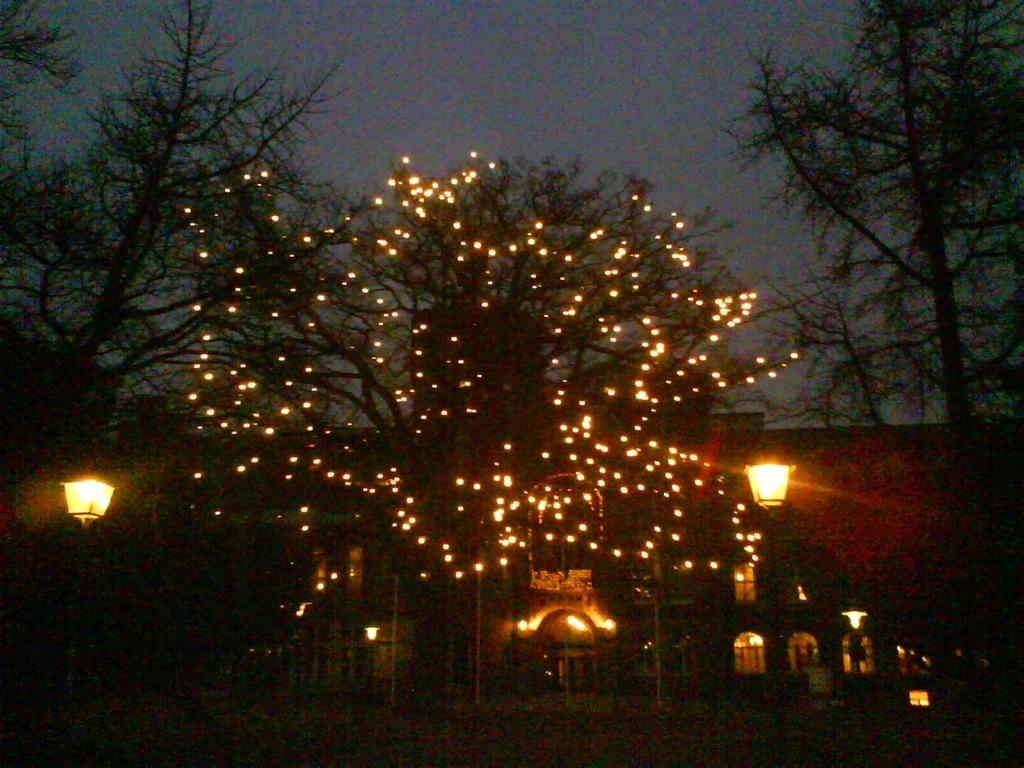What type of structure is present in the image? There is a building in the image. What other objects can be seen in the image? There are light poles and trees in the image. What is visible in the background of the image? The sky is visible in the image. Can you describe a specific tree in the image? There is a tree decorated with tiny lights in the image. Are there any fairies flying around the decorated tree in the image? There is no indication of fairies in the image; it only shows a building, light poles, trees, and a tree decorated with tiny lights. 